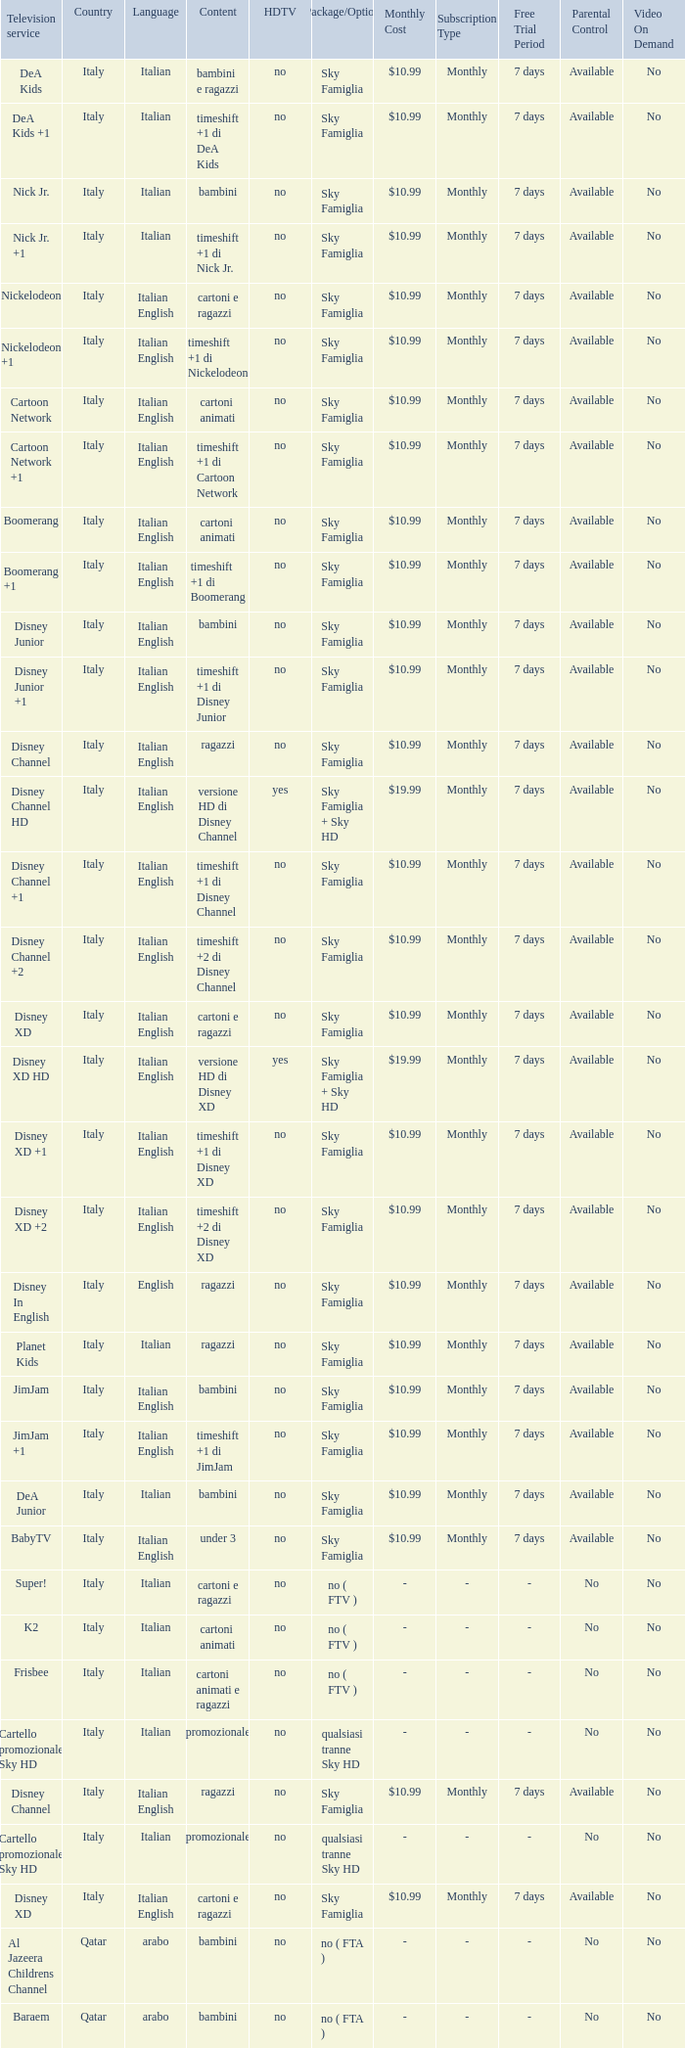What is the HDTV when the Package/Option is sky famiglia, and a Television service of boomerang +1? No. 